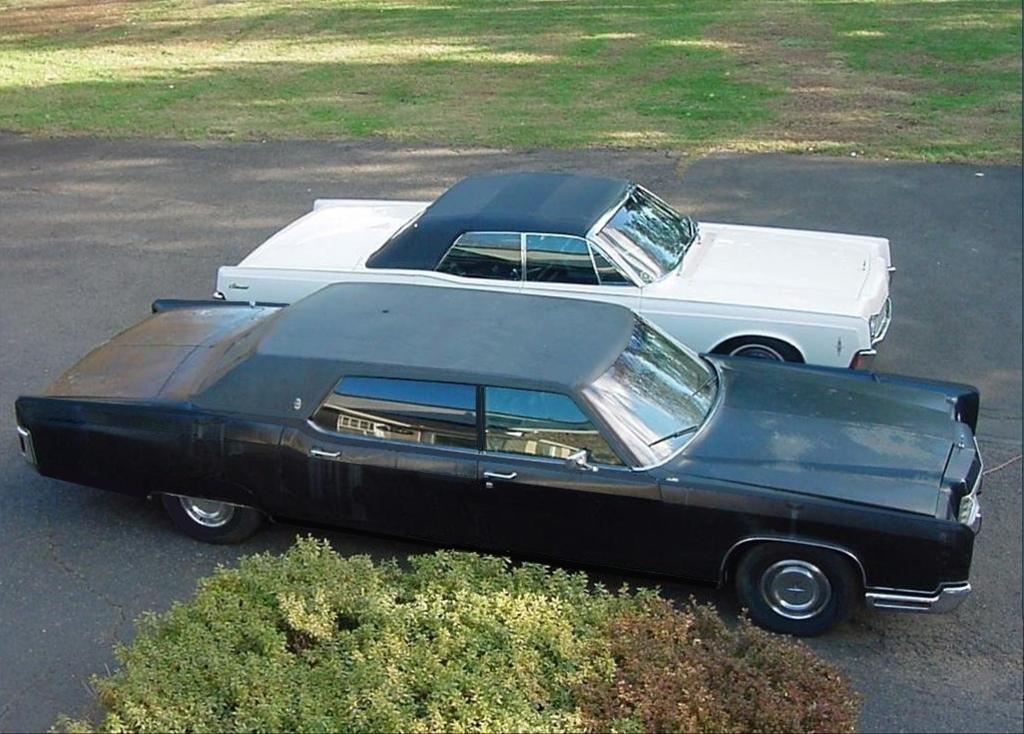What type of terrain is visible in the image? There is grass in the image. What type of man-made structure is present in the image? There is a road in the image. How many cars are in the image? There are two cars in the image. What are the colors of the cars? One car is black, and the other car is black and white. What other natural elements can be seen in the image? There are plants in the image. Where is the laborer working in the image? There is no laborer present in the image. What type of kettle is visible in the image? There is no kettle present in the image. 